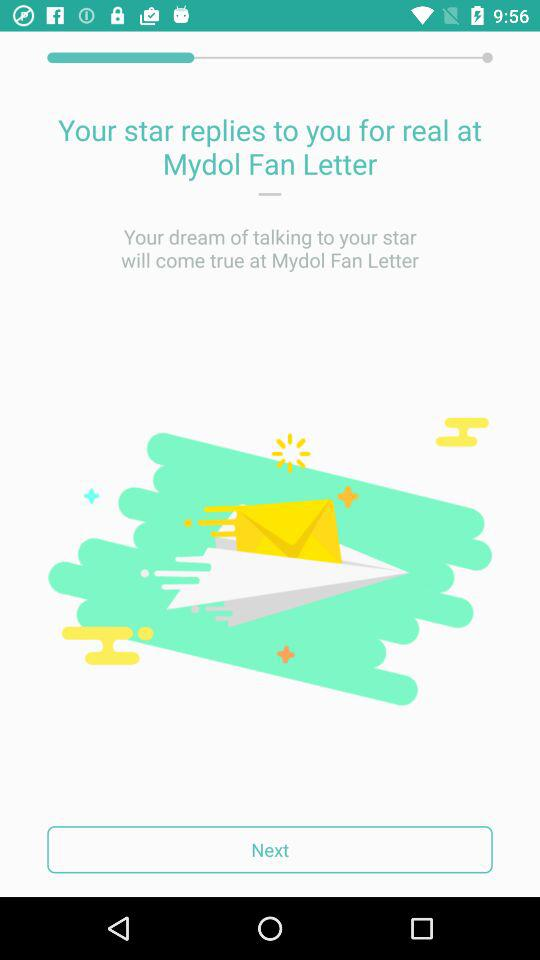"Mydol Fan Letter" is powered by who?
When the provided information is insufficient, respond with <no answer>. <no answer> 